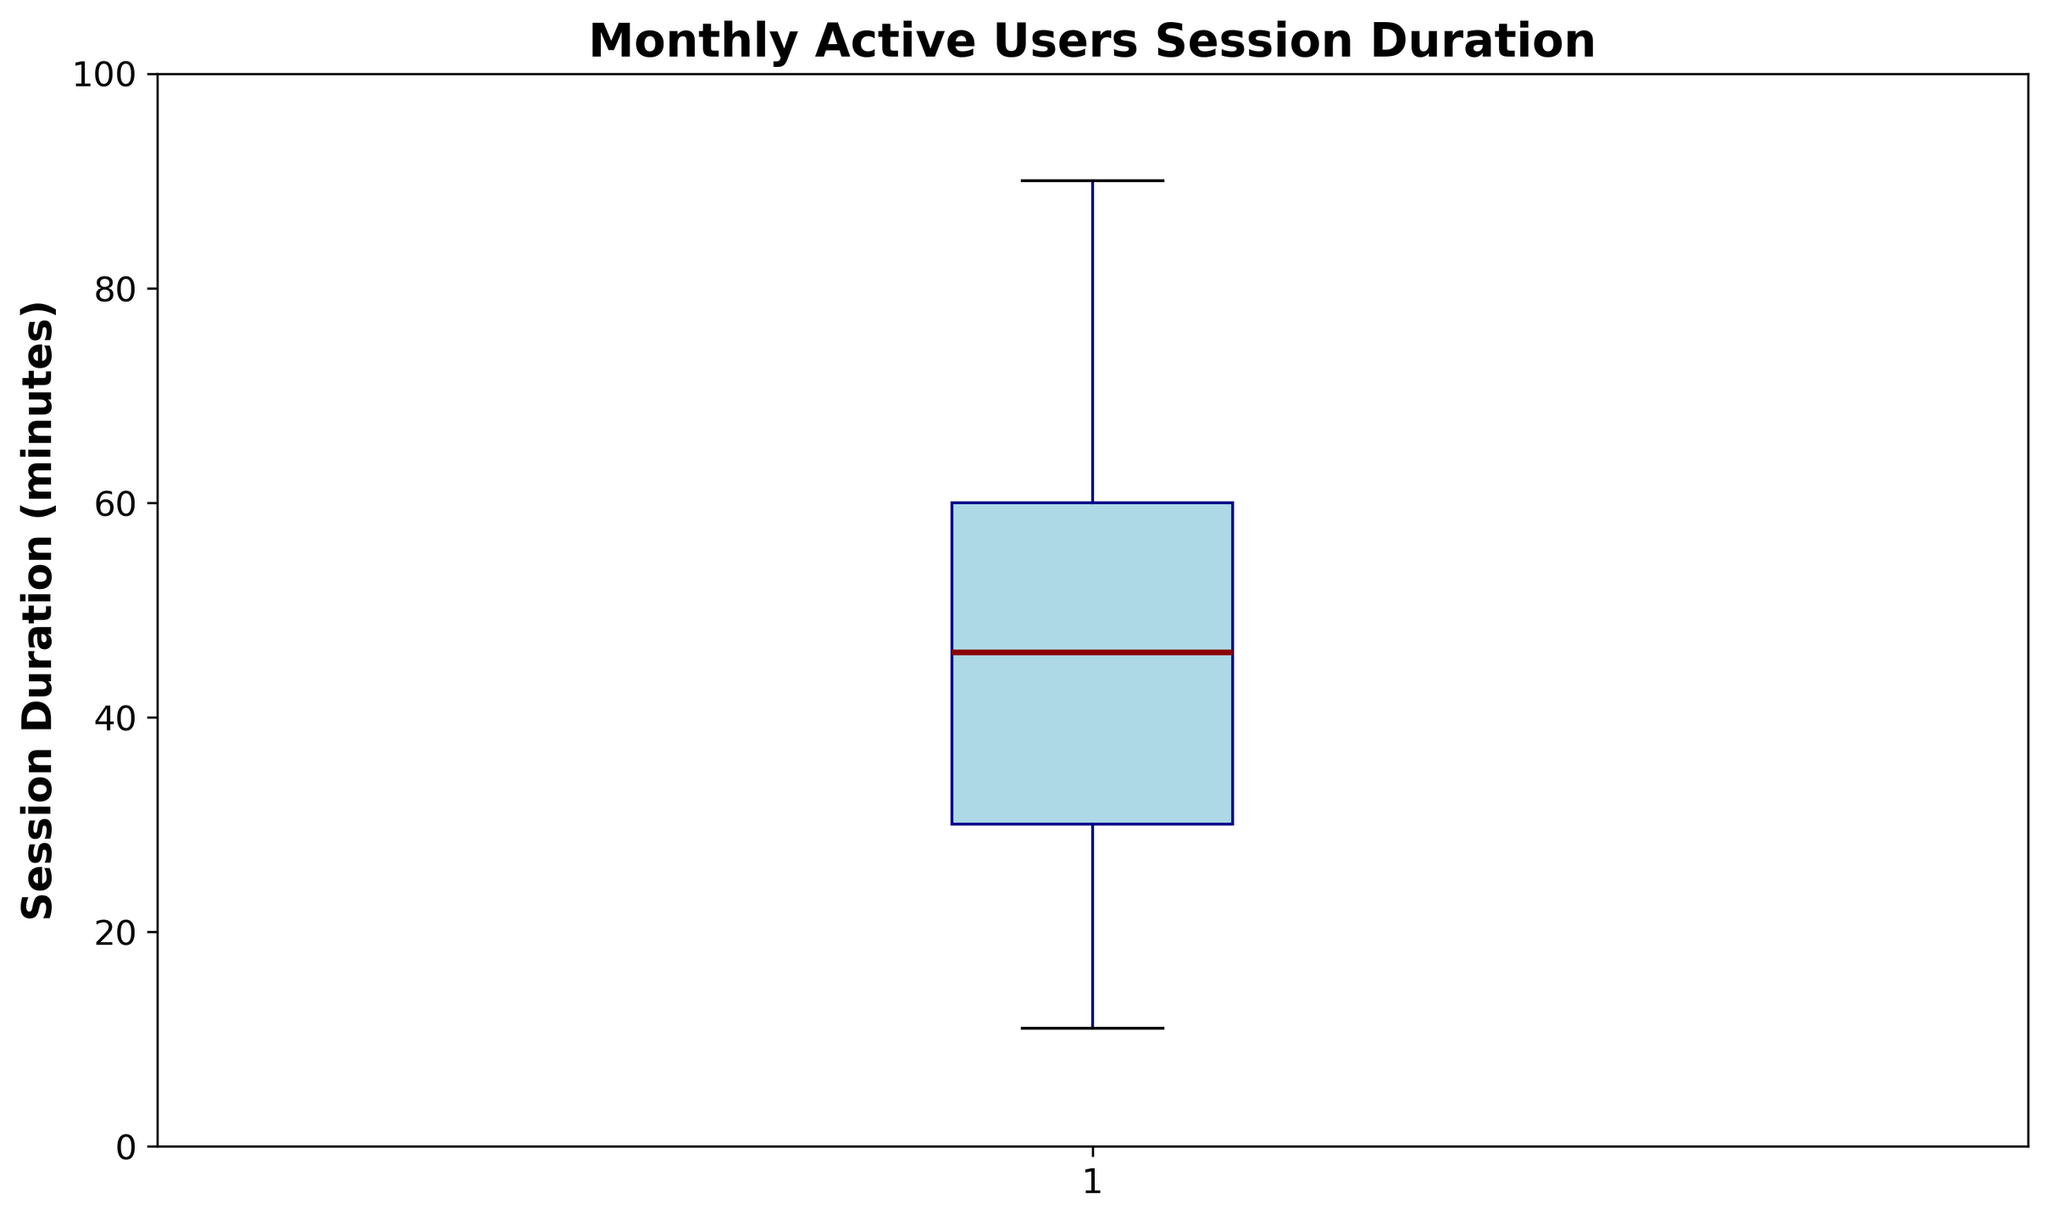What is the range of session durations (the difference between the maximum and minimum values)? To find the range, look at the highest and lowest points in the plot. The maximum session duration value is 90 minutes and the minimum is 11 minutes. Therefore, the range is 90 - 11.
Answer: 79 minutes What is the median session duration? The median is represented by the line within the box in the box plot. From the plot, the line inside the box corresponds to a session duration of approximately 46 minutes.
Answer: 46 minutes What are the interquartile range (IQR) values (the difference between the third and first quartiles)? The IQR is calculated as the difference between the third quartile (Q3) and the first quartile (Q1). These values correspond to the top and bottom of the box in the box plot. From the plot, Q1 is approximately 30 minutes and Q3 is approximately 60 minutes. So, the IQR is 60 - 30.
Answer: 30 minutes What is the difference between the median session duration and the first quartile? The median session duration is approximately 46 minutes, and the first quartile is approximately 30 minutes. The difference is 46 - 30.
Answer: 16 minutes Are there any outliers in the session duration data, and if so, what are their values? Outliers are typically represented by dots outside the whiskers of the box plot. From the plot, there is one outlier at 90 minutes.
Answer: 90 minutes What is the length of the whiskers on the box plot? The whiskers extend from the quartiles to the maximum and minimum values within 1.5*IQR. The lower whisker ends at the minimum value (11 minutes) and the upper whisker ends at the maximum value within 1.5*IQR (around 78 minutes).
Answer: 11 to ~78 minutes Which session duration quartile has the widest spread, and what is the approximate range for that quartile? The quartiles are divided as follows: Q1 to median, median to Q3. From the plot, the quartile from median (~46 minutes) to Q3 (~60 minutes) has a spread of approximately 14 minutes. The quartile from Q1 (~30) to median (~46) has a spread of about 16 minutes. Hence, the spread is widest in the first quartile to median range.
Answer: Q1 to median, approximately 16 minutes How does the median session duration compare to the average session duration? The median session duration is ~46 minutes. To compute the average, sum all session durations and divide by the number of data points. Using the provided data (sum = 4229, number of points = 100), the average session duration is 4229/100. Comparing the two, the median is slightly lower than the average.
Answer: Median is ~46 min, Average is ~42.29 min 